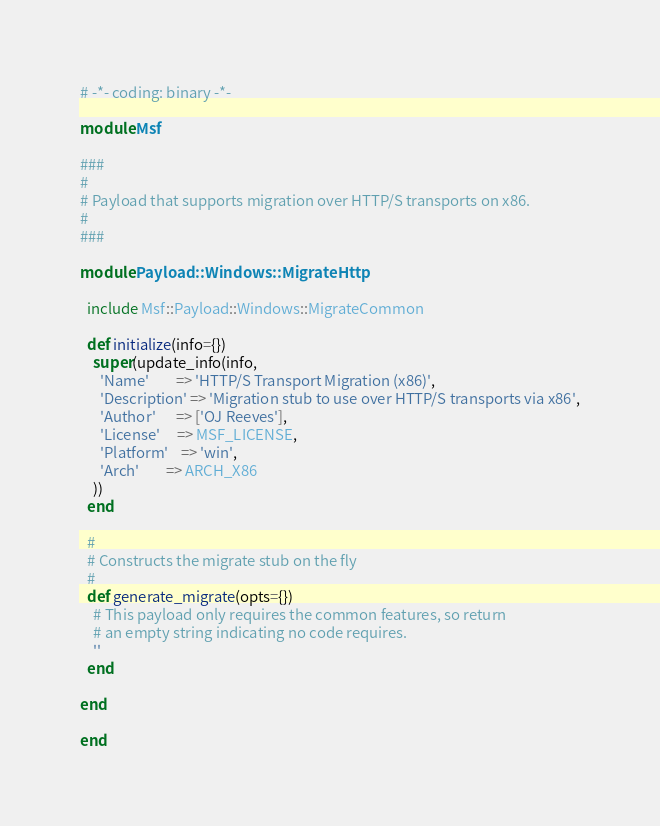<code> <loc_0><loc_0><loc_500><loc_500><_Ruby_># -*- coding: binary -*-

module Msf

###
#
# Payload that supports migration over HTTP/S transports on x86.
#
###

module Payload::Windows::MigrateHttp

  include Msf::Payload::Windows::MigrateCommon

  def initialize(info={})
    super(update_info(info,
      'Name'        => 'HTTP/S Transport Migration (x86)',
      'Description' => 'Migration stub to use over HTTP/S transports via x86',
      'Author'      => ['OJ Reeves'],
      'License'     => MSF_LICENSE,
      'Platform'    => 'win',
      'Arch'        => ARCH_X86
    ))
  end

  #
  # Constructs the migrate stub on the fly
  #
  def generate_migrate(opts={})
    # This payload only requires the common features, so return
    # an empty string indicating no code requires.
    ''
  end

end

end
</code> 